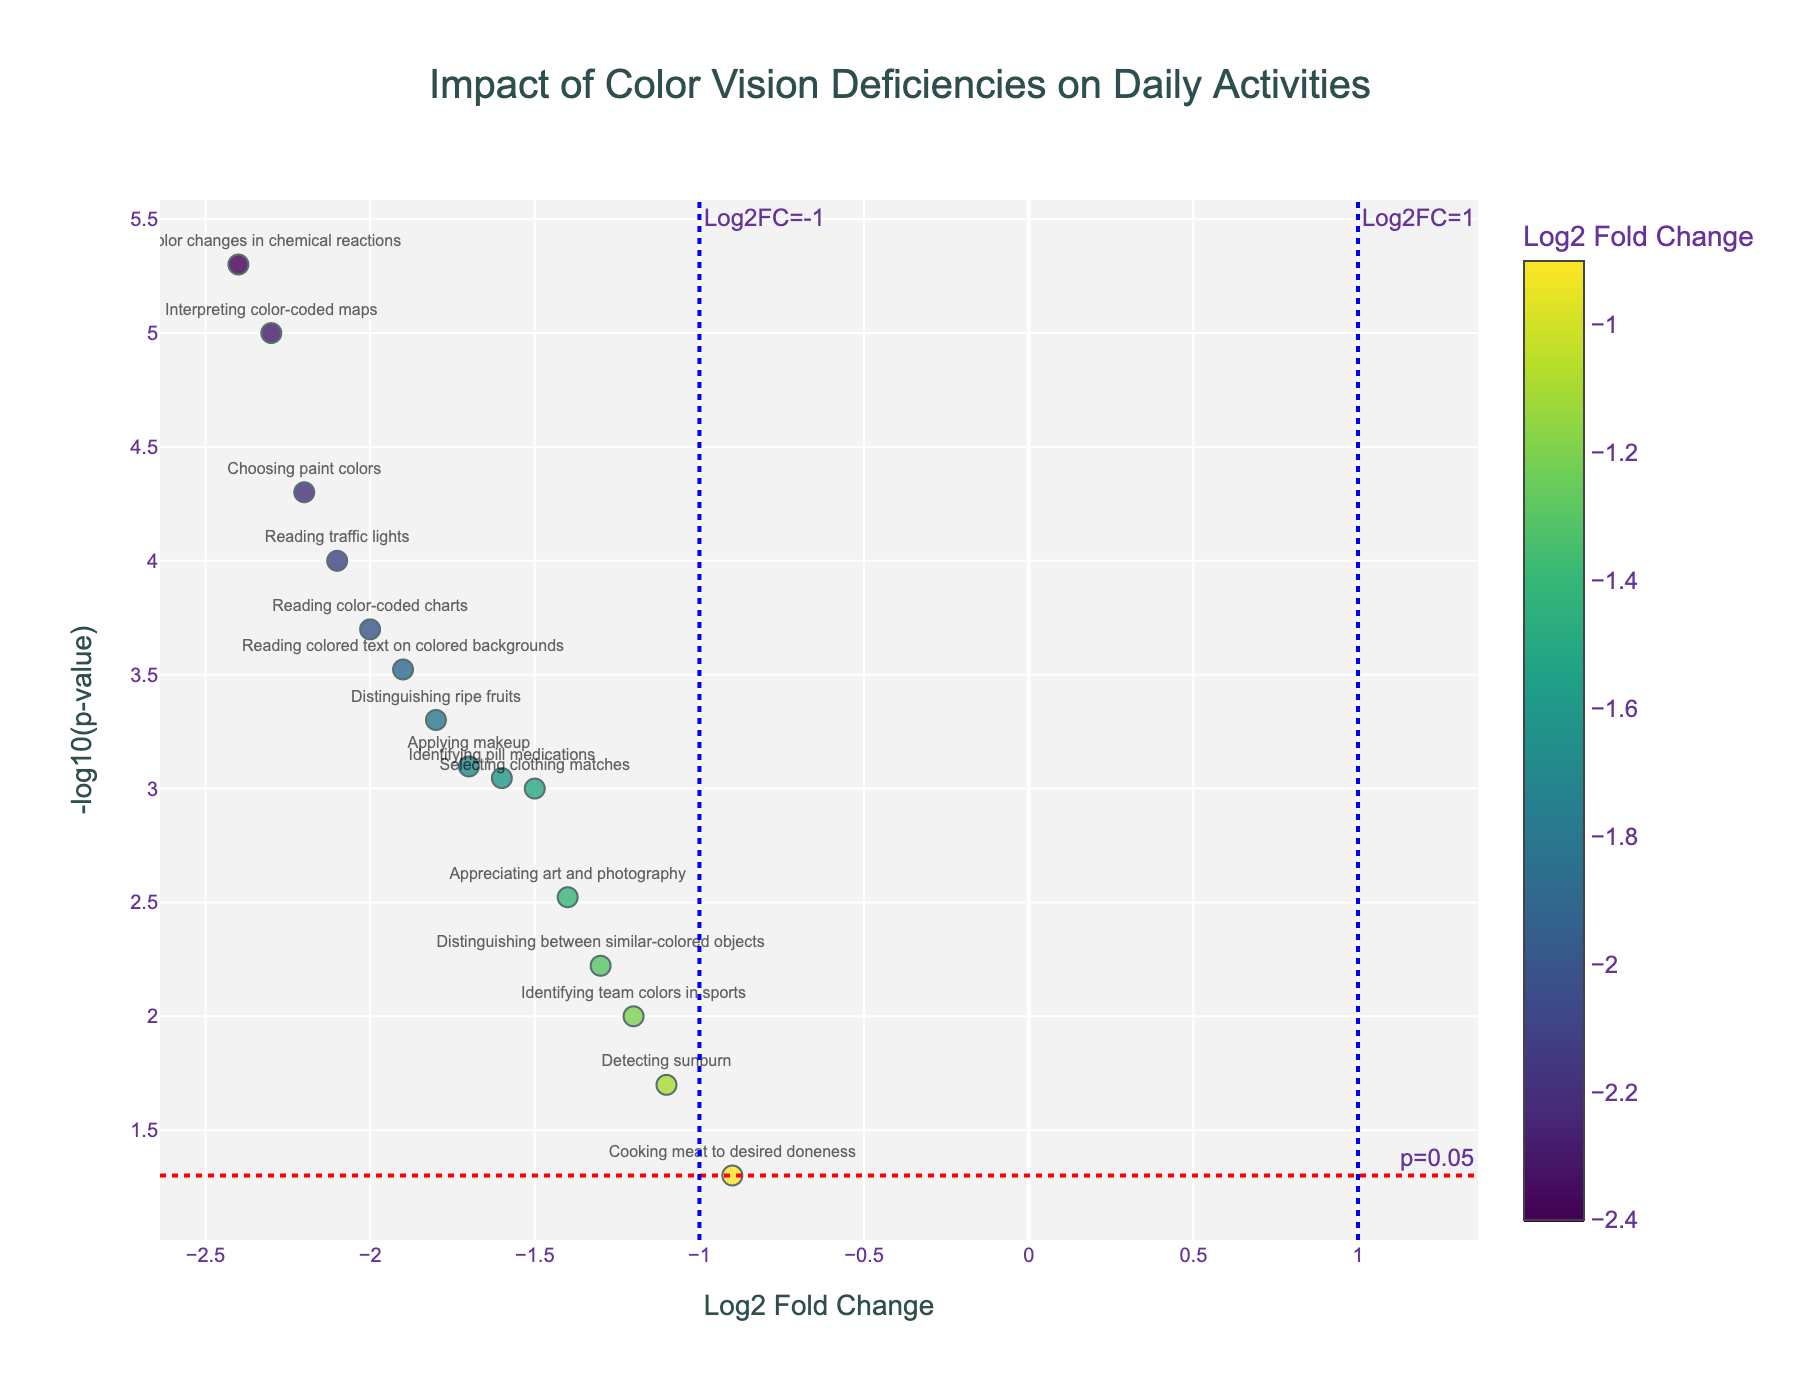How many activities have a log2 fold change of less than -2.0? To determine this, look at the x-axis representing Log2 Fold Change and count the data points where the x-value is less than -2.0.
Answer: 5 What is indicated by the color of the markers? The color of the markers represents the Log2 Fold Change value, with a colorscale shown for reference on the right side of the plot.
Answer: Log2 Fold Change Which activity has the smallest p-value? Examine the y-axis representing -log10(p-value) and identify the data point at the highest y-value. Then refer to the hovertext or label to find the corresponding activity.
Answer: Detecting color changes in chemical reactions Which activity is closest to the threshold line for p-value, and what is that activity's p-value? Identify the activity nearest to the red dashed line representing the p=0.05 threshold (approximately 1.3 on the y-axis) and look for its hovertext or label to find the p-value.
Answer: Cooking meat to desired doneness, 0.05 What does a high value on the y-axis represent? A high value on the y-axis indicates a very small p-value, showing that the result is statistically significant.
Answer: Smaller p-value What is the most impacted activity with a log2 fold change of around -2? Find datas at the x-axis around -2 and check the respective activity label or hovertext to identify the activity most impacted.
Answer: Reading traffic lights Are there any activities that do not meet both significance thresholds (p=0.05 and Log2FC=-1)? Look for data points that are below the red dashed line and between the blue dashed lines on the x-axis.
Answer: No Between "Choosing paint colors" and "Reading colored text on colored backgrounds", which activity has a higher statistical significance? Compare the y-axis positions of these two activities, and the higher the y-value, the greater the statistical significance.
Answer: Choosing paint colors Which activity has the most critical impact on daily activities, combining both high fold change and high significance? Look for the point furthest to the left (low Log2FC) and highest on the y-axis (high significance), and refer to the label or hovertext for the respective activity.
Answer: Detecting color changes in chemical reactions For the activities closest to the Log2FC=-1 line, which has the lower p-value? Find data points nearest to the vertical blue dashed line at Log2FC=-1 and compare their y-axis positions to see which has the highest -log10(p-value).
Answer: Identifying team colors in sports 